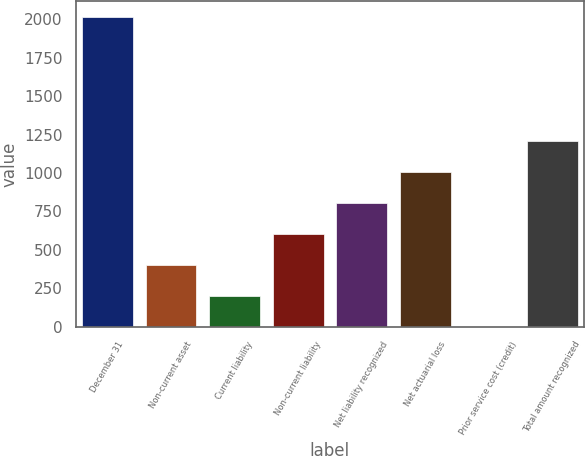Convert chart. <chart><loc_0><loc_0><loc_500><loc_500><bar_chart><fcel>December 31<fcel>Non-current asset<fcel>Current liability<fcel>Non-current liability<fcel>Net liability recognized<fcel>Net actuarial loss<fcel>Prior service cost (credit)<fcel>Total amount recognized<nl><fcel>2017<fcel>403.56<fcel>201.88<fcel>605.24<fcel>806.92<fcel>1008.6<fcel>0.2<fcel>1210.28<nl></chart> 